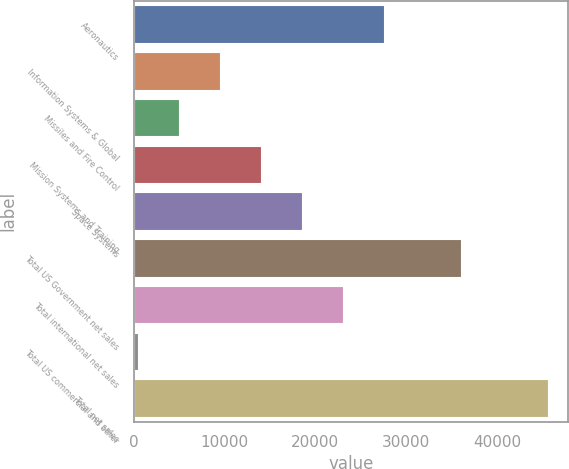Convert chart. <chart><loc_0><loc_0><loc_500><loc_500><bar_chart><fcel>Aeronautics<fcel>Information Systems & Global<fcel>Missiles and Fire Control<fcel>Mission Systems and Training<fcel>Space Systems<fcel>Total US Government net sales<fcel>Total international net sales<fcel>Total US commercial and other<fcel>Total net sales<nl><fcel>27558<fcel>9516<fcel>5005.5<fcel>14026.5<fcel>18537<fcel>36090<fcel>23047.5<fcel>495<fcel>45600<nl></chart> 